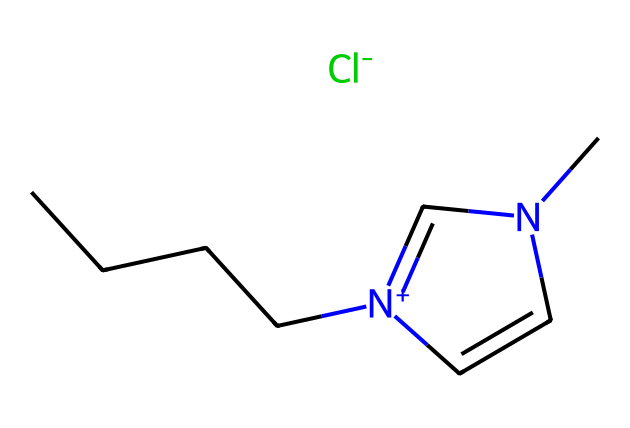What is the molecular formula of 1-butyl-3-methylimidazolium chloride? The molecular formula can be determined by analyzing the SMILES representation, which indicates the presence of 1 butyl group (C4H9), a methyl group (CH3), the imidazolium ring with its components (C3H3N2), and a chloride ion (Cl). By summing these components, we find the total formula is C7H14ClN2.
Answer: C7H14ClN2 How many carbon atoms are present in the structure? By analyzing the SMILES representation, we see the butyl chain made of 4 carbon atoms (CCCC), 1 carbon atom from the methyl group (C), and 3 carbon atoms in the imidazolium ring (n1ccn). Thus, there are 8 carbon atoms in total.
Answer: 8 What type of ionic liquid is 1-butyl-3-methylimidazolium chloride? This ionic liquid is categorized as an imidazolium-based ionic liquid, as seen from the presence of the imidazolium ring structure noted in the SMILES.
Answer: imidazolium-based Which functional group does the chloride ion represent in this ionic liquid? The chloride ion (Cl-) acts as the anion in this ionic liquid structure. It signifies the ionic pairing with the cation, here being the butyl-methylimidazolium component, contributing to the overall ionic liquid properties.
Answer: anion What is the charge of the nitrogen atom in 1-butyl-3-methylimidazolium? The nitrogen atom within the imidazolium ring is positively charged (denoted by [n+]), indicating it is a cationic species in the ionic liquid structure.
Answer: positive Is 1-butyl-3-methylimidazolium chloride hydrophilic or hydrophobic? The presence of both hydrophobic butyl groups and a hydrophilic imidazolium cation suggests that it is amphiphilic; however, due to the strong ionic character, it generally displays hydrophilic behavior.
Answer: hydrophilic 